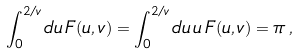Convert formula to latex. <formula><loc_0><loc_0><loc_500><loc_500>\int _ { 0 } ^ { 2 / v } d u \, F ( u , v ) = \int _ { 0 } ^ { 2 / v } d u \, u \, F ( u , v ) = \pi \, ,</formula> 